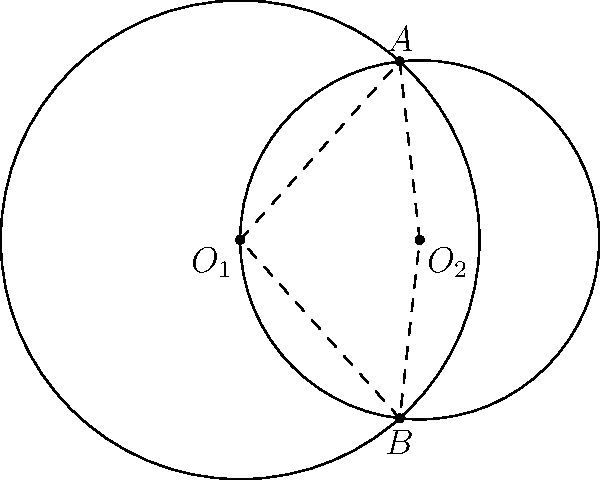As a sales executive, you're presenting a new product launch strategy. The finance team has provided you with a Venn diagram-like visualization of market overlap between two product lines. The circles represent the market reach of each product, with radii of 4 and 3 units, and their centers are 3 units apart. What's the area of the overlapping region (shaded area) between these two market segments? Round your answer to two decimal places. Let's approach this step-by-step:

1) We have two circles with radii $r_1 = 4$ and $r_2 = 3$, and their centers are 3 units apart.

2) The area of the overlapping region can be calculated using the formula:

   $$A = r_1^2 \arccos(\frac{d^2 + r_1^2 - r_2^2}{2dr_1}) + r_2^2 \arccos(\frac{d^2 + r_2^2 - r_1^2}{2dr_2}) - \frac{1}{2}\sqrt{(-d+r_1+r_2)(d+r_1-r_2)(d-r_1+r_2)(d+r_1+r_2)}$$

   where $d$ is the distance between the centers.

3) Let's substitute our values:
   $r_1 = 4$, $r_2 = 3$, $d = 3$

4) Calculating each part:
   
   $$\arccos(\frac{3^2 + 4^2 - 3^2}{2 * 3 * 4}) = \arccos(\frac{25}{24}) = 0.2838 \text{ radians}$$
   
   $$\arccos(\frac{3^2 + 3^2 - 4^2}{2 * 3 * 3}) = \arccos(\frac{2}{6}) = 1.2870 \text{ radians}$$
   
   $$\sqrt{(-3+4+3)(3+4-3)(3-4+3)(3+4+3)} = \sqrt{4 * 4 * 2 * 10} = 8$$

5) Putting it all together:

   $$A = 4^2 * 0.2838 + 3^2 * 1.2870 - \frac{1}{2} * 8$$
   
   $$A = 4.5408 + 11.5830 - 4 = 12.1238$$

6) Rounding to two decimal places: 12.12
Answer: 12.12 square units 